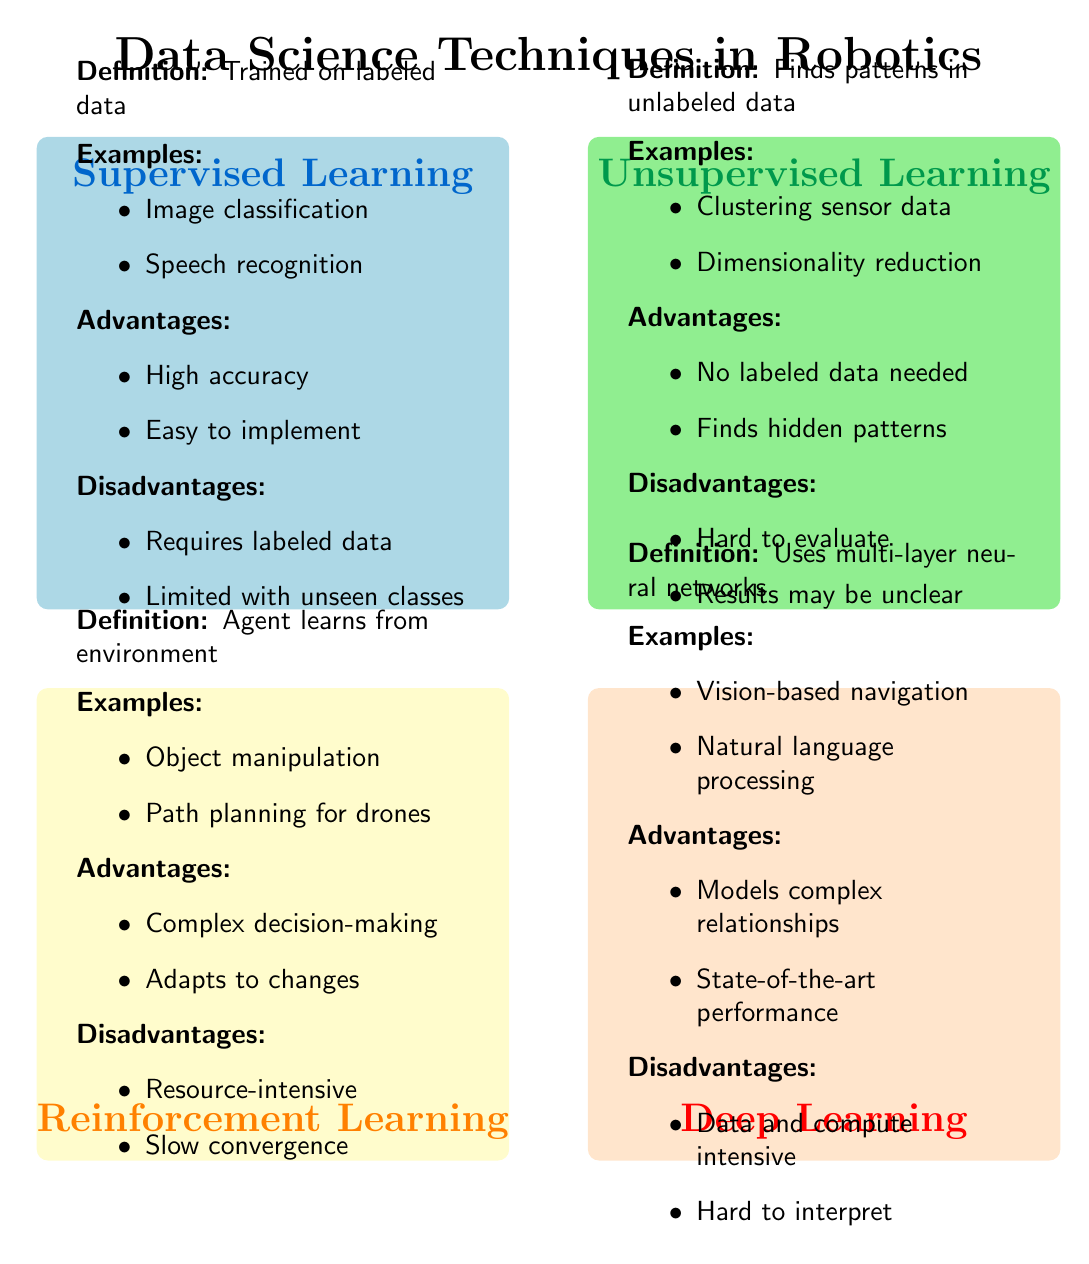What is the definition of supervised learning? The definition of supervised learning is found in the quadrant labeled "Supervised Learning" and is specified as "A type of machine learning where the model is trained on labeled data."
Answer: A type of machine learning where the model is trained on labeled data How many examples are listed for deep learning? To find out how many examples are listed for deep learning, I can look in the quadrant labeled "Deep Learning" and count the items in the "Examples" section, which has two examples.
Answer: Two What are the advantages of unsupervised learning? The advantages of unsupervised learning are listed in the "Advantages" section of the "Unsupervised Learning" quadrant, which includes "No need for labeled data" and "Can find hidden patterns and structures."
Answer: No need for labeled data; can find hidden patterns and structures Which learning method requires a large amount of labeled data? By examining the "Disadvantages" section of the "Supervised Learning" quadrant, the phrase "Requires a large amount of labeled data" indicates that this method falls under supervised learning.
Answer: Supervised learning Which quadrant has the example "Vision-based navigation for autonomous vehicles"? This example can be found in the "Examples" section of the quadrant labeled "Deep Learning," confirming that this quadrant contains the specified example.
Answer: Deep Learning What is a disadvantage of reinforcement learning? The "Disadvantages" section of the "Reinforcement Learning" quadrant lists two issues: "Requires a lot of computational resources" and "May take a long time to converge," thus indicating the disadvantages of this learning method.
Answer: Requires a lot of computational resources; may take a long time to converge Which two learning methods do not require labeled data? Both unsupervised learning, as stated in its definition, and the second section of its advantages ("No need for labeled data") support the answer, combined with the fact that reinforcement learning focuses on actions in an environment rather than labeled data.
Answer: Unsupervised learning; reinforcement learning What is the title of the diagram? The title of the diagram can be determined from the node labeled at the top of the quadrant chart, which reads "Data Science Techniques in Robotics."
Answer: Data Science Techniques in Robotics What are the two main types of neural networks mentioned in deep learning? To find the main types of neural networks in deep learning, I can look in the "Definition" section of the "Deep Learning" quadrant, which states that deep learning uses "neural networks with many layers."
Answer: Neural networks with many layers 